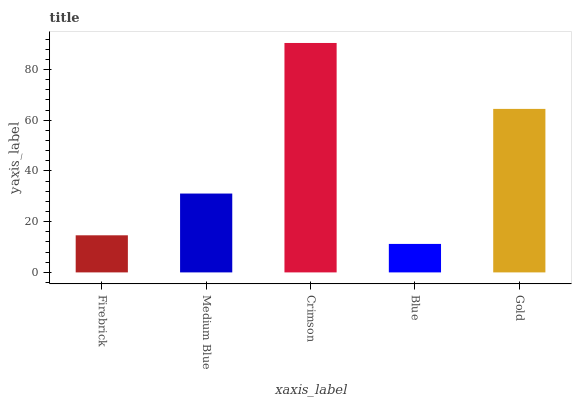Is Blue the minimum?
Answer yes or no. Yes. Is Crimson the maximum?
Answer yes or no. Yes. Is Medium Blue the minimum?
Answer yes or no. No. Is Medium Blue the maximum?
Answer yes or no. No. Is Medium Blue greater than Firebrick?
Answer yes or no. Yes. Is Firebrick less than Medium Blue?
Answer yes or no. Yes. Is Firebrick greater than Medium Blue?
Answer yes or no. No. Is Medium Blue less than Firebrick?
Answer yes or no. No. Is Medium Blue the high median?
Answer yes or no. Yes. Is Medium Blue the low median?
Answer yes or no. Yes. Is Crimson the high median?
Answer yes or no. No. Is Firebrick the low median?
Answer yes or no. No. 